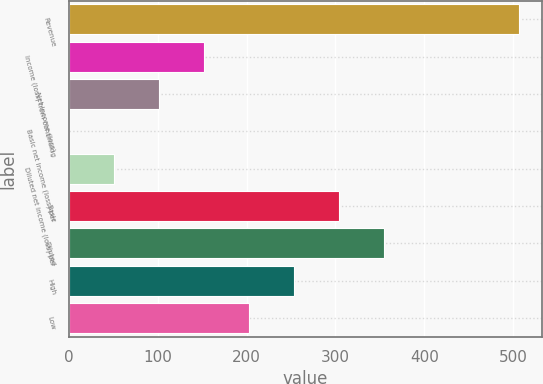Convert chart to OTSL. <chart><loc_0><loc_0><loc_500><loc_500><bar_chart><fcel>Revenue<fcel>Income (loss) from continuing<fcel>Net income (loss)<fcel>Basic net income (loss) per<fcel>Diluted net income (loss) per<fcel>Basic<fcel>Diluted<fcel>High<fcel>Low<nl><fcel>506.9<fcel>152.19<fcel>101.52<fcel>0.18<fcel>50.85<fcel>304.2<fcel>354.87<fcel>253.53<fcel>202.86<nl></chart> 